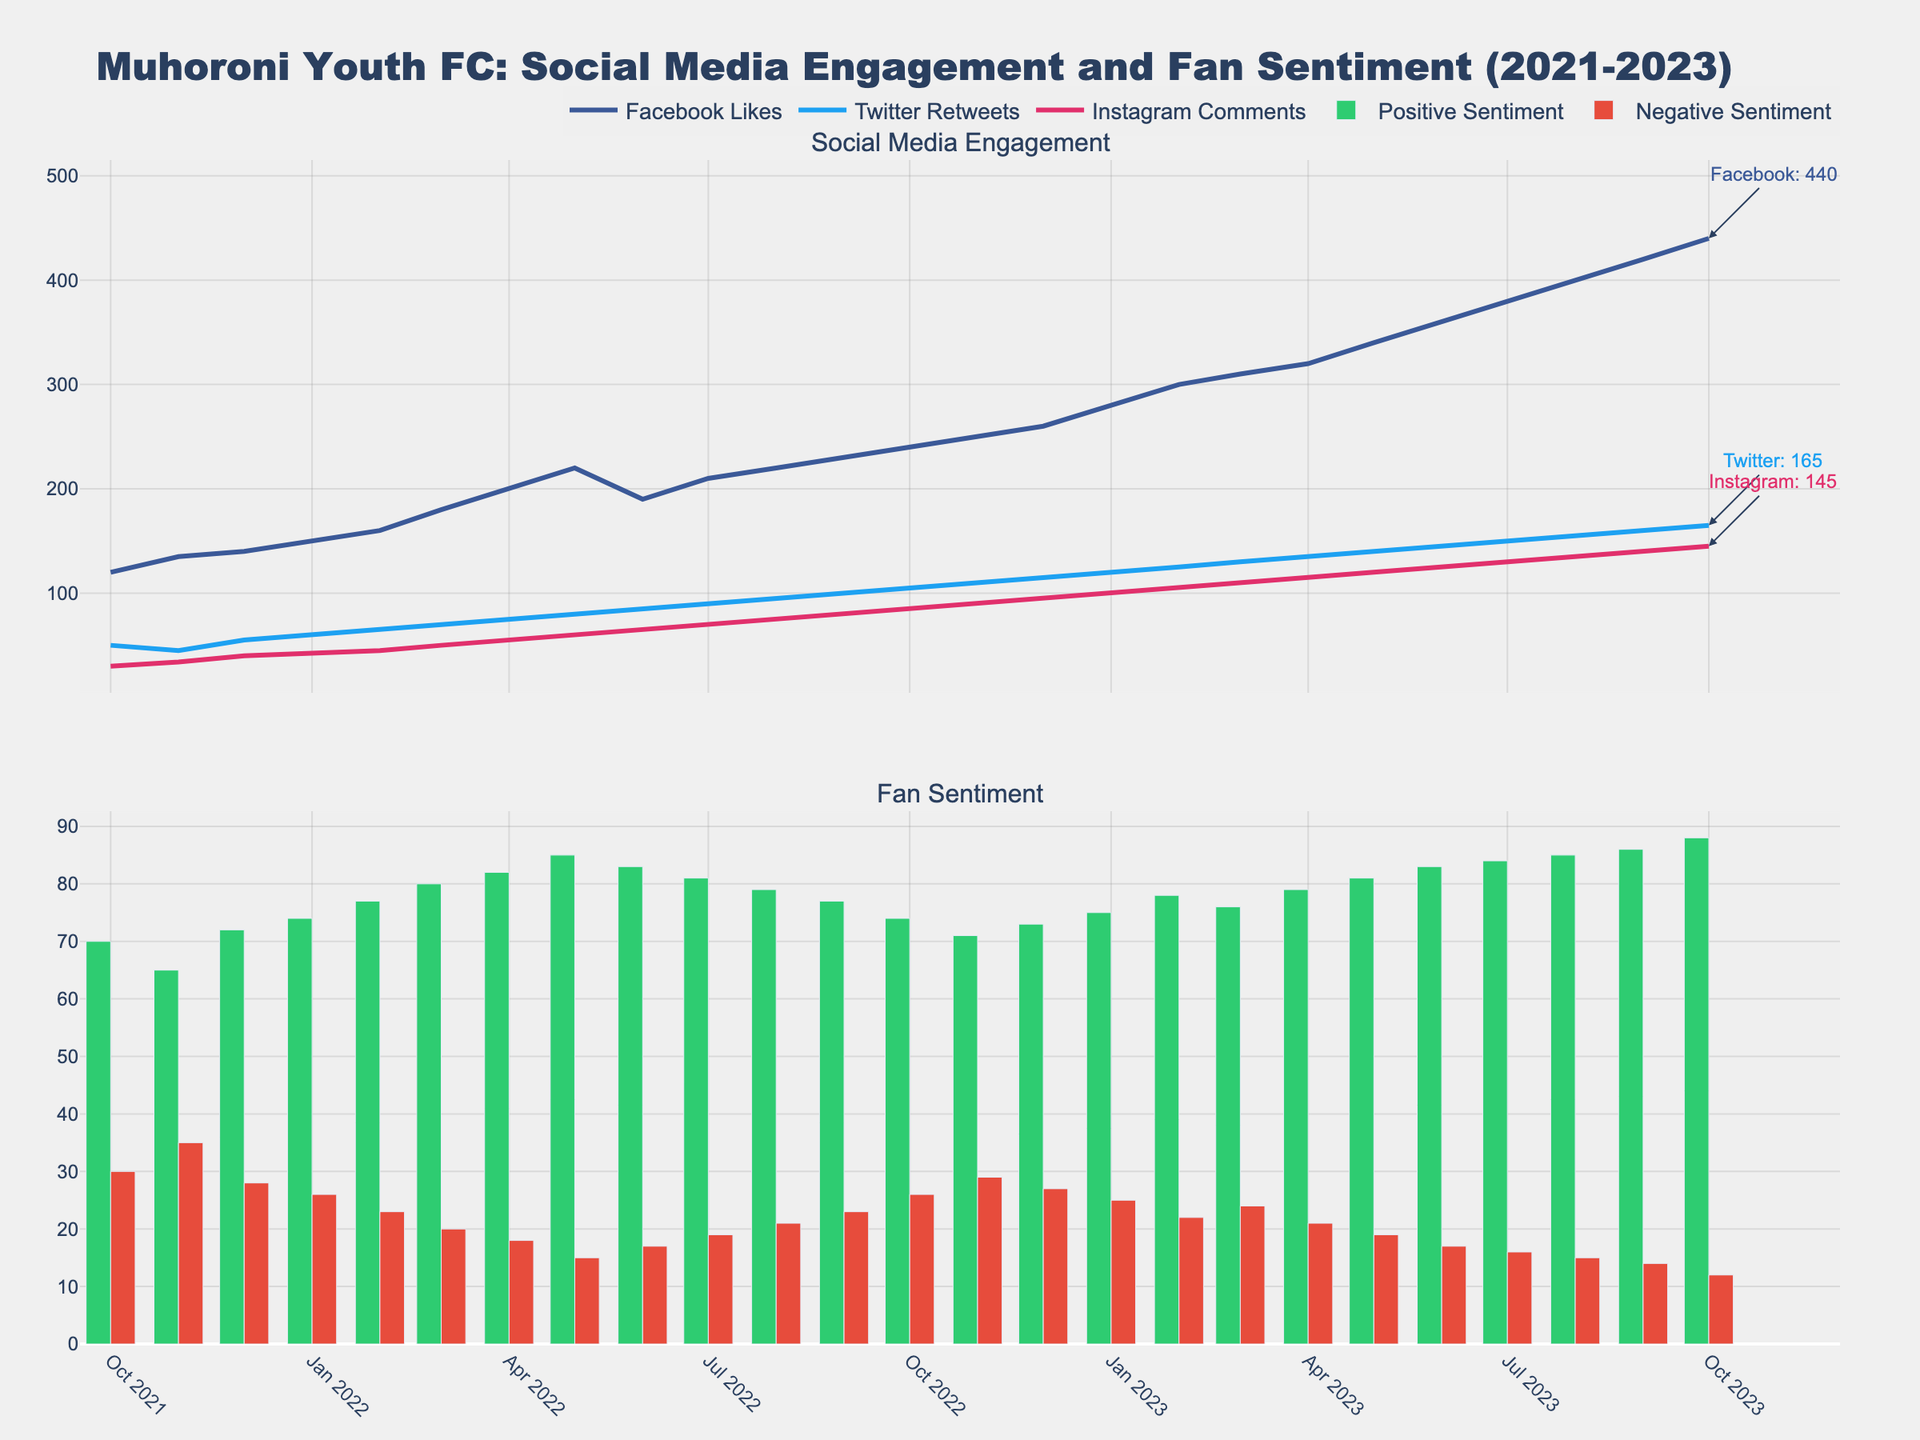What is the title of the figure? The title is usually placed at the top of the figure and is written in large, bold font.
Answer: Muhoroni Youth FC: Social Media Engagement and Fan Sentiment (2021-2023) What are the different social media metrics tracked in the first subplot? By observing the labels of the lines in the first subplot, we can identify the social media metrics being tracked.
Answer: Facebook Likes, Twitter Retweets, Instagram Comments Which social media platform showed the highest engagement on the most recent date? We check the annotations at the end of each line in the first subplot for the most recent date to identify the highest engagement.
Answer: Facebook How does the positive sentiment trend over the last two years? We observe the height of the green bars in the second subplot across different dates to understand the trend.
Answer: Increasing What is the total number of Facebook Likes in August 2022? We locate the point on the Facebook Likes line that corresponds to August 2022.
Answer: 220 Compare the number of Twitter Retweets between January 2022 and January 2023. Which month had more? We look at the values on the Twitter Retweets line for January 2022 and January 2023 to compare them.
Answer: January 2023 On which month did Facebook Likes first surpass 300? We look for the first date on the Facebook Likes line where the value exceeds 300.
Answer: February 2023 What is the highest recorded negative sentiment value, and when did it occur? We identify the tallest red bar in the second subplot and note the corresponding date.
Answer: 35, November 2021 What can you say about Instagram Comments' trend from October 2021 to October 2023? We observe the line representing Instagram Comments in the first subplot from start to end to see how it changes.
Answer: Steadily increasing Is there any correlation between social media engagement and positive sentiment over the time period? By observing the overall trends in both subplots, we can comment on whether increases in engagement metrics coincide with increased positive sentiment.
Answer: Generally, yes 